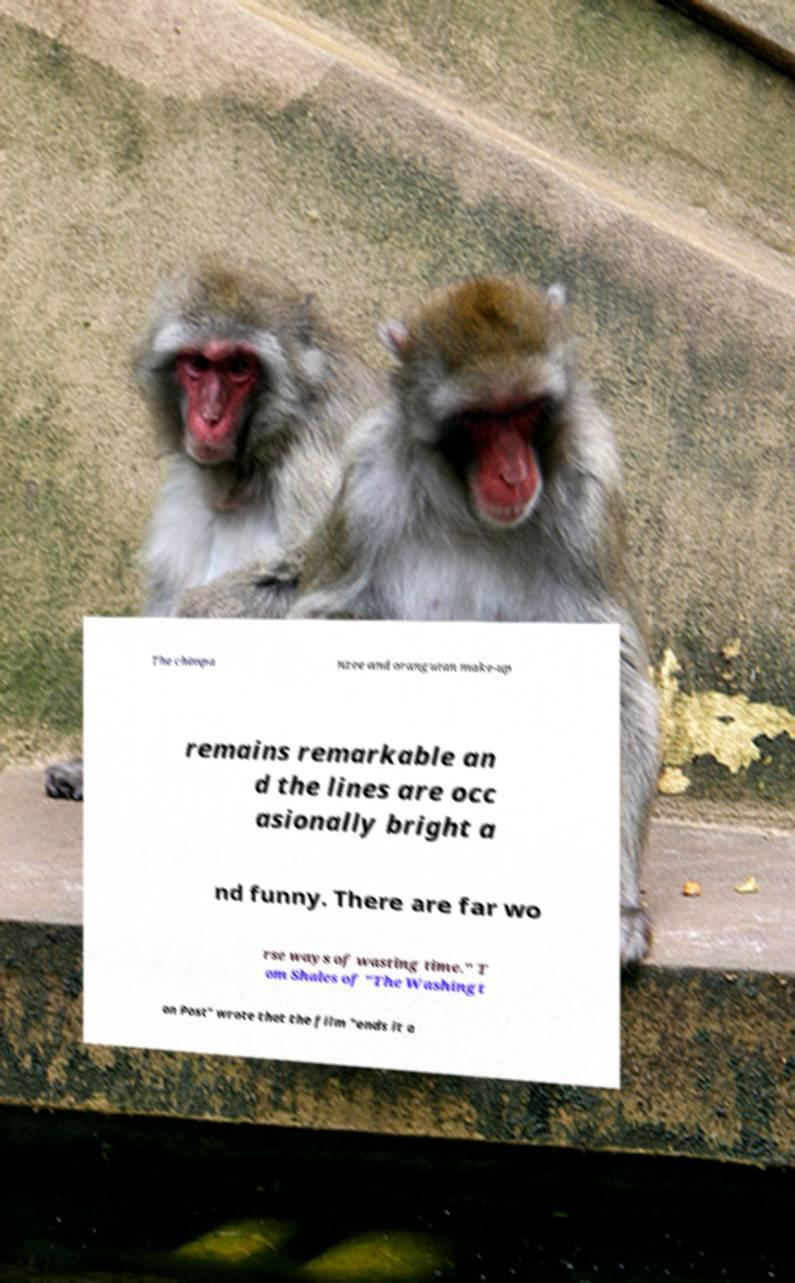There's text embedded in this image that I need extracted. Can you transcribe it verbatim? The chimpa nzee and orangutan make-up remains remarkable an d the lines are occ asionally bright a nd funny. There are far wo rse ways of wasting time." T om Shales of "The Washingt on Post" wrote that the film "ends it a 